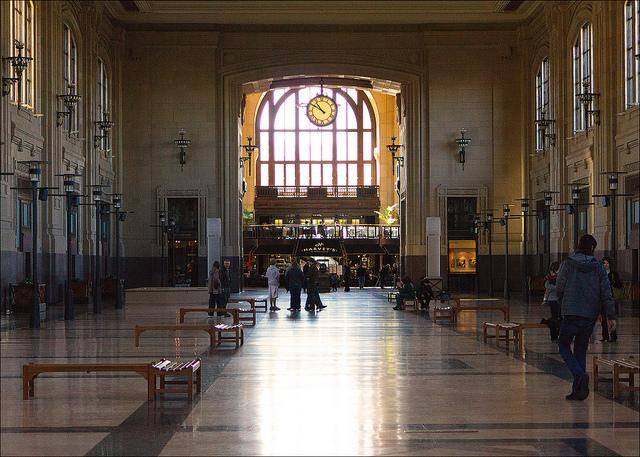What is on the left side of the room? benches 